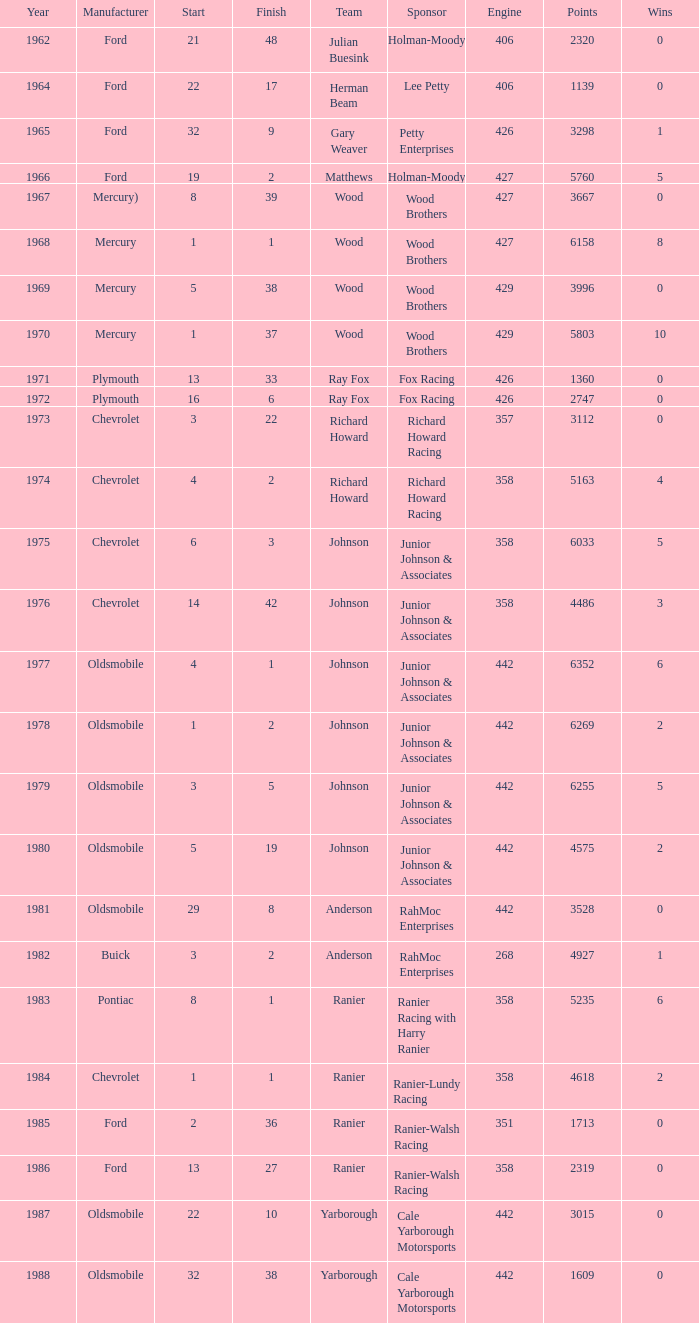What is the smallest finish time for a race after 1972 with a car manufactured by pontiac? 1.0. Can you parse all the data within this table? {'header': ['Year', 'Manufacturer', 'Start', 'Finish', 'Team', 'Sponsor', 'Engine', 'Points', 'Wins'], 'rows': [['1962', 'Ford', '21', '48', 'Julian Buesink', 'Holman-Moody', '406', '2320', '0'], ['1964', 'Ford', '22', '17', 'Herman Beam', 'Lee Petty', '406', '1139', '0'], ['1965', 'Ford', '32', '9', 'Gary Weaver', 'Petty Enterprises', '426', '3298', '1'], ['1966', 'Ford', '19', '2', 'Matthews', 'Holman-Moody', '427', '5760', '5'], ['1967', 'Mercury)', '8', '39', 'Wood', 'Wood Brothers', '427', '3667', '0'], ['1968', 'Mercury', '1', '1', 'Wood', 'Wood Brothers', '427', '6158', '8'], ['1969', 'Mercury', '5', '38', 'Wood', 'Wood Brothers', '429', '3996', '0'], ['1970', 'Mercury', '1', '37', 'Wood', 'Wood Brothers', '429', '5803', '10'], ['1971', 'Plymouth', '13', '33', 'Ray Fox', 'Fox Racing', '426', '1360', '0'], ['1972', 'Plymouth', '16', '6', 'Ray Fox', 'Fox Racing', '426', '2747', '0'], ['1973', 'Chevrolet', '3', '22', 'Richard Howard', 'Richard Howard Racing', '357', '3112', '0'], ['1974', 'Chevrolet', '4', '2', 'Richard Howard', 'Richard Howard Racing', '358', '5163', '4'], ['1975', 'Chevrolet', '6', '3', 'Johnson', 'Junior Johnson & Associates', '358', '6033', '5'], ['1976', 'Chevrolet', '14', '42', 'Johnson', 'Junior Johnson & Associates', '358', '4486', '3'], ['1977', 'Oldsmobile', '4', '1', 'Johnson', 'Junior Johnson & Associates', '442', '6352', '6'], ['1978', 'Oldsmobile', '1', '2', 'Johnson', 'Junior Johnson & Associates', '442', '6269', '2'], ['1979', 'Oldsmobile', '3', '5', 'Johnson', 'Junior Johnson & Associates', '442', '6255', '5'], ['1980', 'Oldsmobile', '5', '19', 'Johnson', 'Junior Johnson & Associates', '442', '4575', '2'], ['1981', 'Oldsmobile', '29', '8', 'Anderson', 'RahMoc Enterprises', '442', '3528', '0'], ['1982', 'Buick', '3', '2', 'Anderson', 'RahMoc Enterprises', '268', '4927', '1'], ['1983', 'Pontiac', '8', '1', 'Ranier', 'Ranier Racing with Harry Ranier', '358', '5235', '6'], ['1984', 'Chevrolet', '1', '1', 'Ranier', 'Ranier-Lundy Racing', '358', '4618', '2'], ['1985', 'Ford', '2', '36', 'Ranier', 'Ranier-Walsh Racing', '351', '1713', '0'], ['1986', 'Ford', '13', '27', 'Ranier', 'Ranier-Walsh Racing', '358', '2319', '0'], ['1987', 'Oldsmobile', '22', '10', 'Yarborough', 'Cale Yarborough Motorsports', '442', '3015', '0'], ['1988', 'Oldsmobile', '32', '38', 'Yarborough', 'Cale Yarborough Motorsports', '442', '1609', '0']]} 